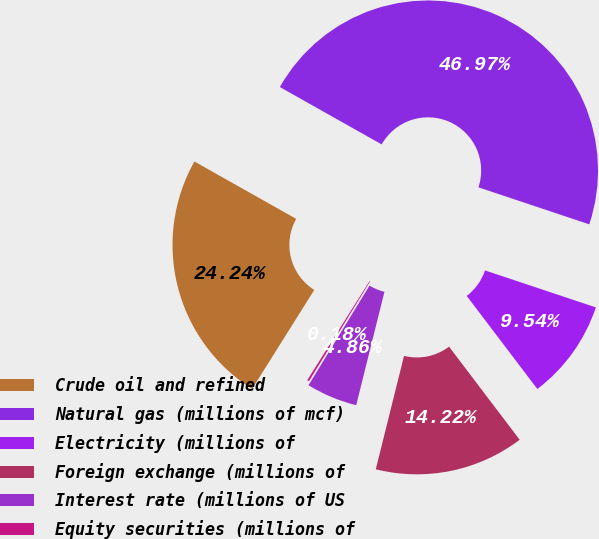<chart> <loc_0><loc_0><loc_500><loc_500><pie_chart><fcel>Crude oil and refined<fcel>Natural gas (millions of mcf)<fcel>Electricity (millions of<fcel>Foreign exchange (millions of<fcel>Interest rate (millions of US<fcel>Equity securities (millions of<nl><fcel>24.24%<fcel>46.97%<fcel>9.54%<fcel>14.22%<fcel>4.86%<fcel>0.18%<nl></chart> 